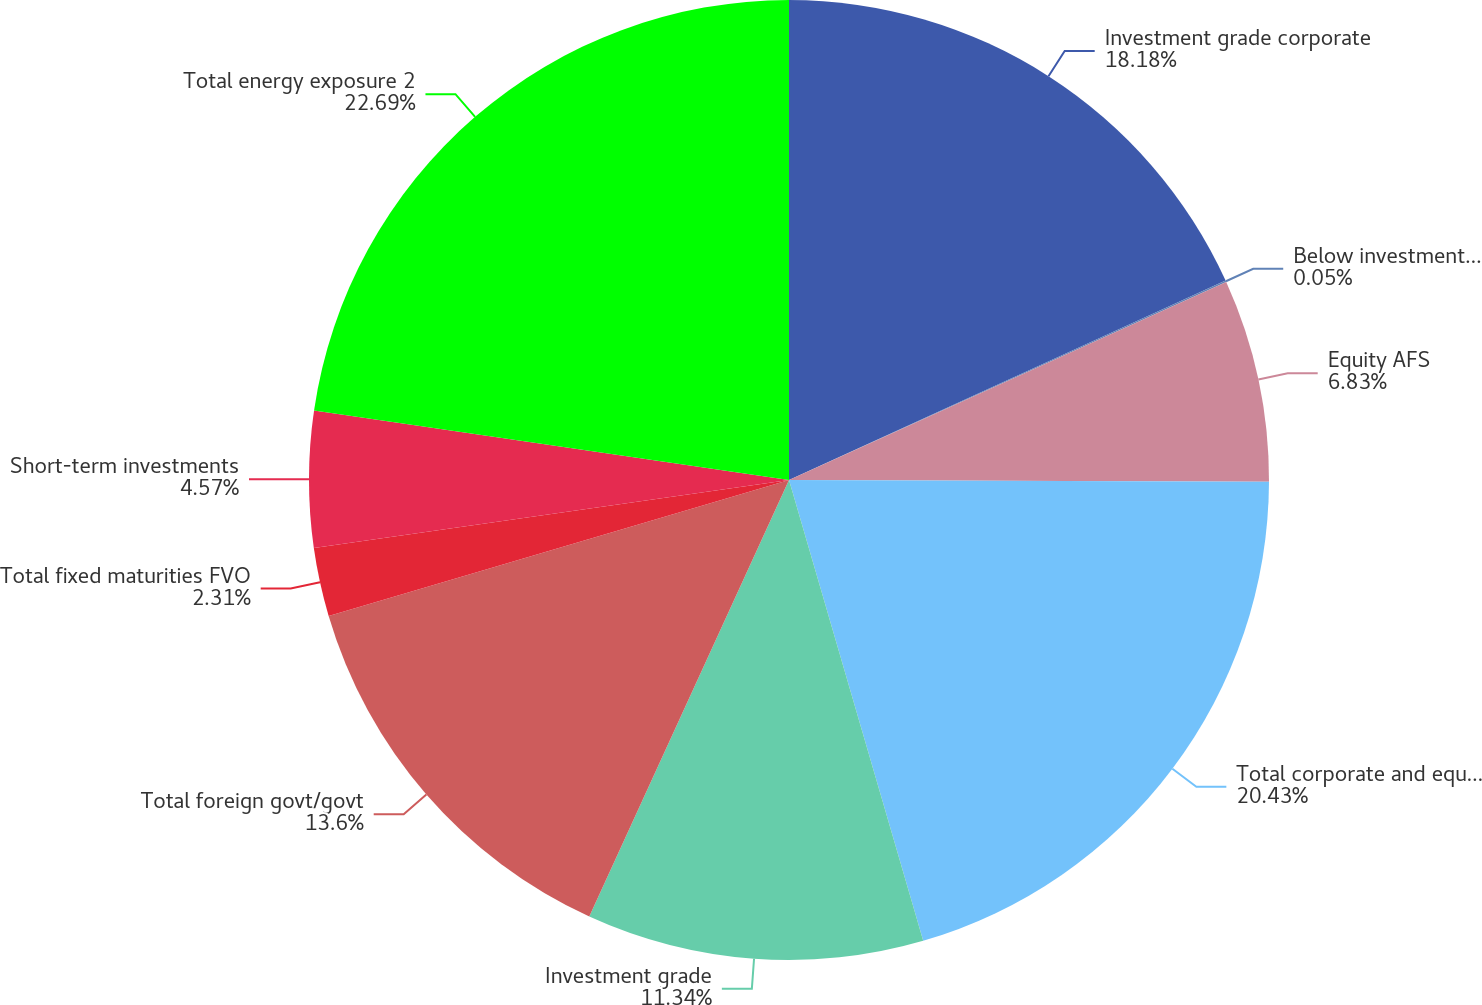Convert chart to OTSL. <chart><loc_0><loc_0><loc_500><loc_500><pie_chart><fcel>Investment grade corporate<fcel>Below investment grade<fcel>Equity AFS<fcel>Total corporate and equity<fcel>Investment grade<fcel>Total foreign govt/govt<fcel>Total fixed maturities FVO<fcel>Short-term investments<fcel>Total energy exposure 2<nl><fcel>18.18%<fcel>0.05%<fcel>6.83%<fcel>20.43%<fcel>11.34%<fcel>13.6%<fcel>2.31%<fcel>4.57%<fcel>22.69%<nl></chart> 